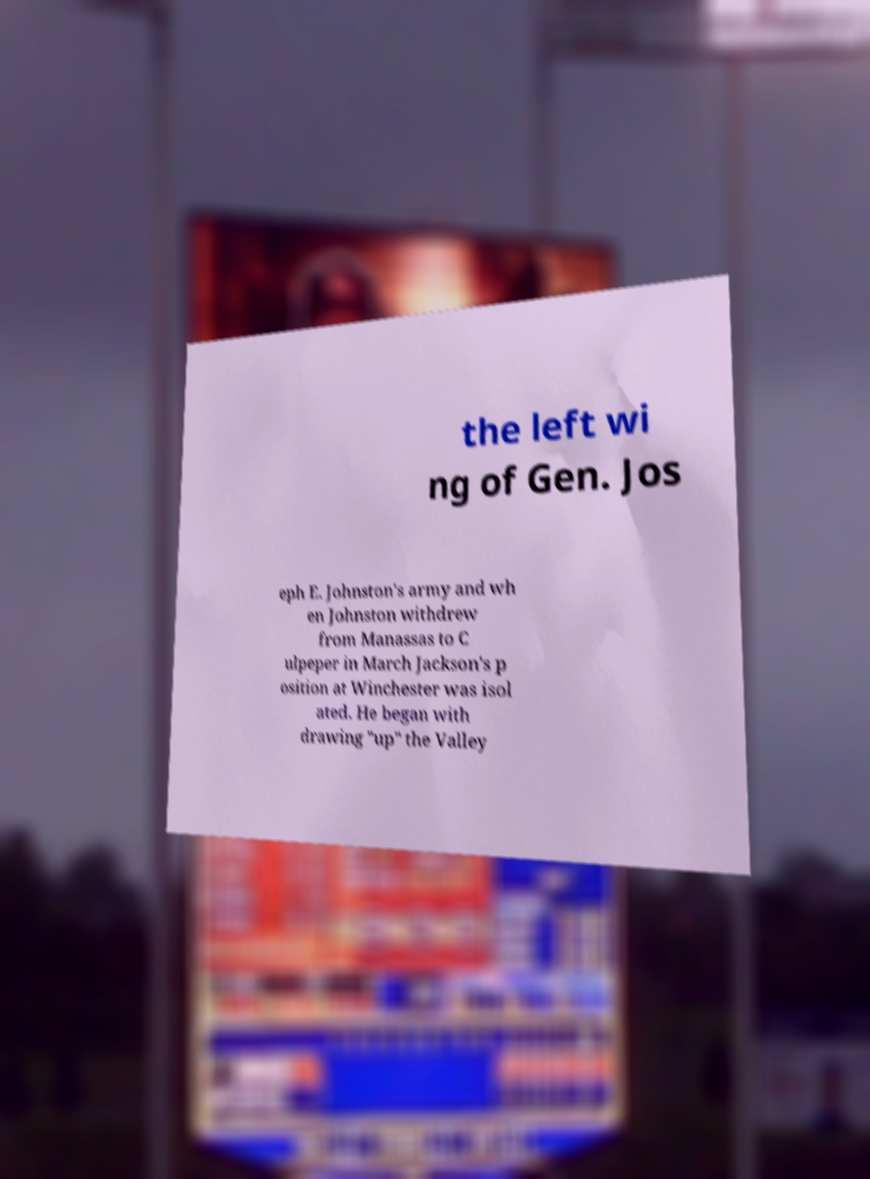I need the written content from this picture converted into text. Can you do that? the left wi ng of Gen. Jos eph E. Johnston's army and wh en Johnston withdrew from Manassas to C ulpeper in March Jackson's p osition at Winchester was isol ated. He began with drawing "up" the Valley 